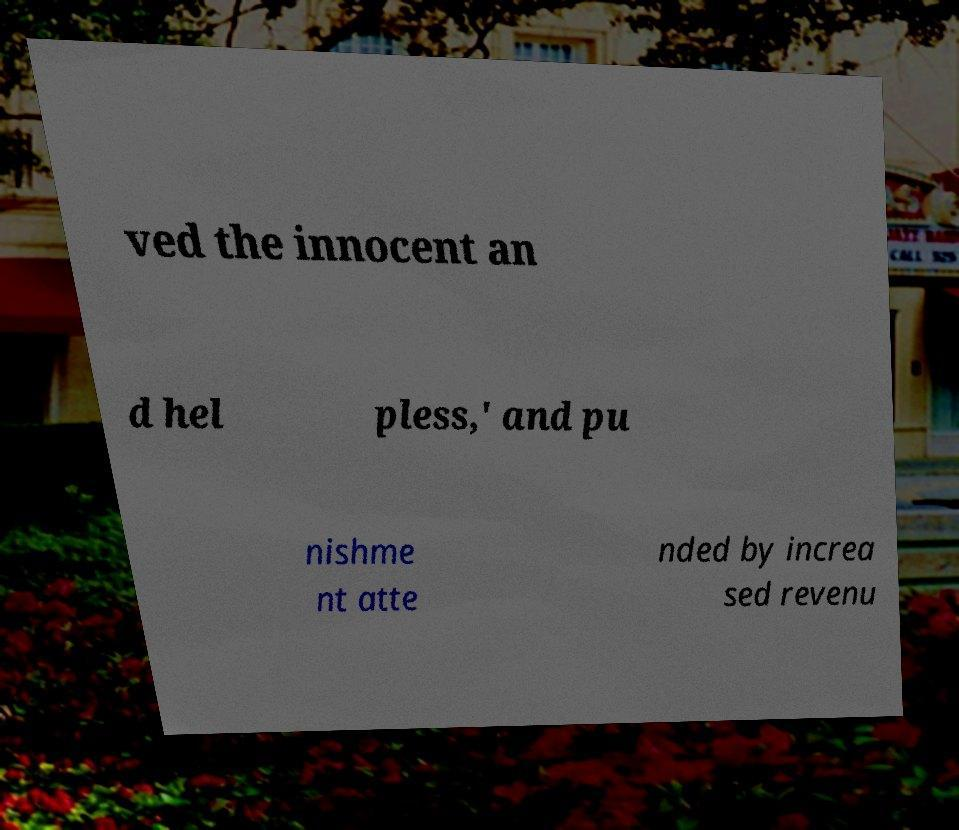What messages or text are displayed in this image? I need them in a readable, typed format. ved the innocent an d hel pless,' and pu nishme nt atte nded by increa sed revenu 